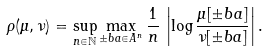<formula> <loc_0><loc_0><loc_500><loc_500>\rho ( \mu , \nu ) = \sup _ { n \in { \mathbb { N } } } \max _ { \pm b { a } \in A ^ { n } } \frac { 1 } { n } \, \left | \log \frac { \mu [ \pm b a ] } { \nu [ \pm b a ] } \right | .</formula> 